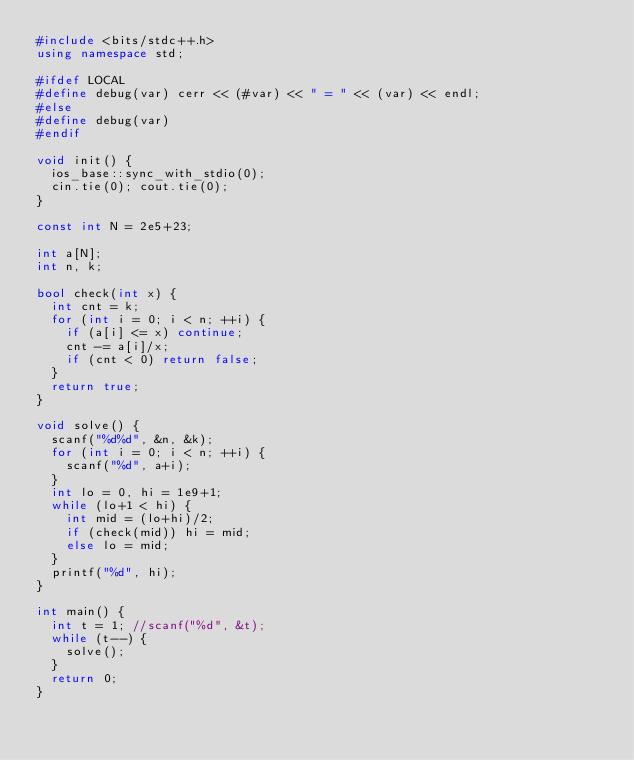<code> <loc_0><loc_0><loc_500><loc_500><_C++_>#include <bits/stdc++.h>
using namespace std;

#ifdef LOCAL
#define debug(var) cerr << (#var) << " = " << (var) << endl;
#else
#define debug(var)
#endif

void init() {
  ios_base::sync_with_stdio(0);
  cin.tie(0); cout.tie(0);
}

const int N = 2e5+23;

int a[N];
int n, k;

bool check(int x) {
  int cnt = k;
  for (int i = 0; i < n; ++i) {
    if (a[i] <= x) continue;
    cnt -= a[i]/x;
    if (cnt < 0) return false;
  }
  return true;
}

void solve() {
  scanf("%d%d", &n, &k);
  for (int i = 0; i < n; ++i) {
    scanf("%d", a+i);
  }
  int lo = 0, hi = 1e9+1;
  while (lo+1 < hi) {
    int mid = (lo+hi)/2;
    if (check(mid)) hi = mid;
    else lo = mid;
  }
  printf("%d", hi);
}

int main() {
  int t = 1; //scanf("%d", &t);
  while (t--) {
    solve();
  }
  return 0;
}
</code> 